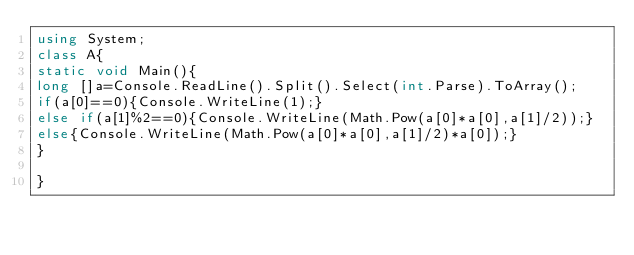<code> <loc_0><loc_0><loc_500><loc_500><_C#_>using System;
class A{
static void Main(){
long []a=Console.ReadLine().Split().Select(int.Parse).ToArray();
if(a[0]==0){Console.WriteLine(1);}
else if(a[1]%2==0){Console.WriteLine(Math.Pow(a[0]*a[0],a[1]/2));}
else{Console.WriteLine(Math.Pow(a[0]*a[0],a[1]/2)*a[0]);}
}

}</code> 